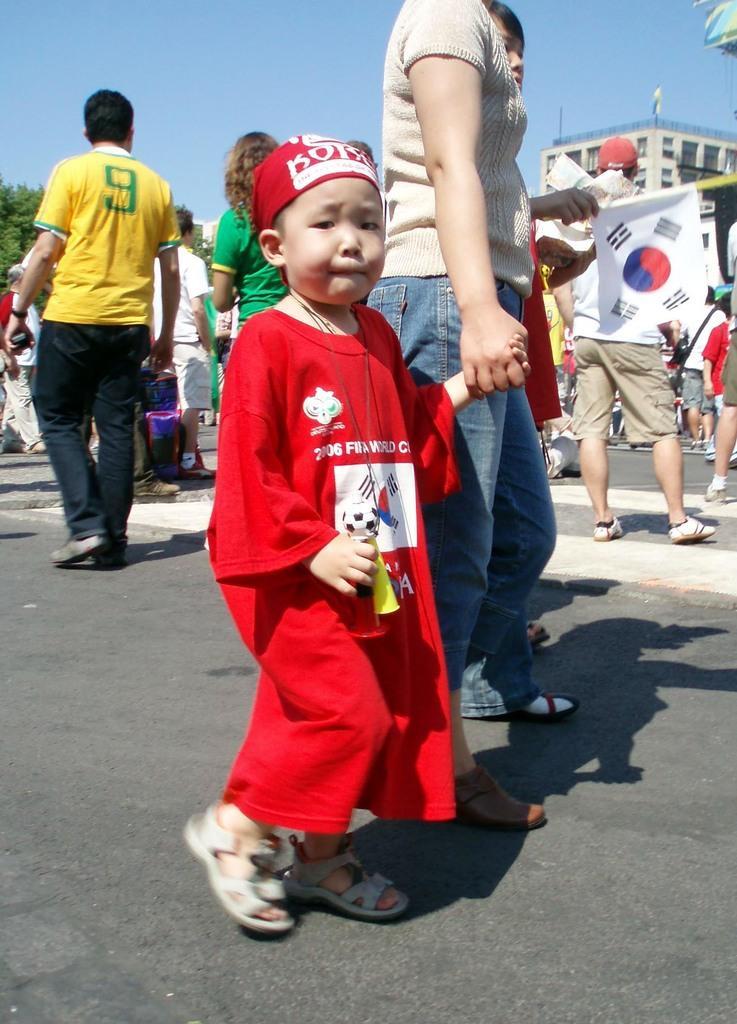Could you give a brief overview of what you see in this image? In this image, I can see a group of people standing on the road. In the background, I can see a building and the sky. On the left side of the image, I can see a tree. 